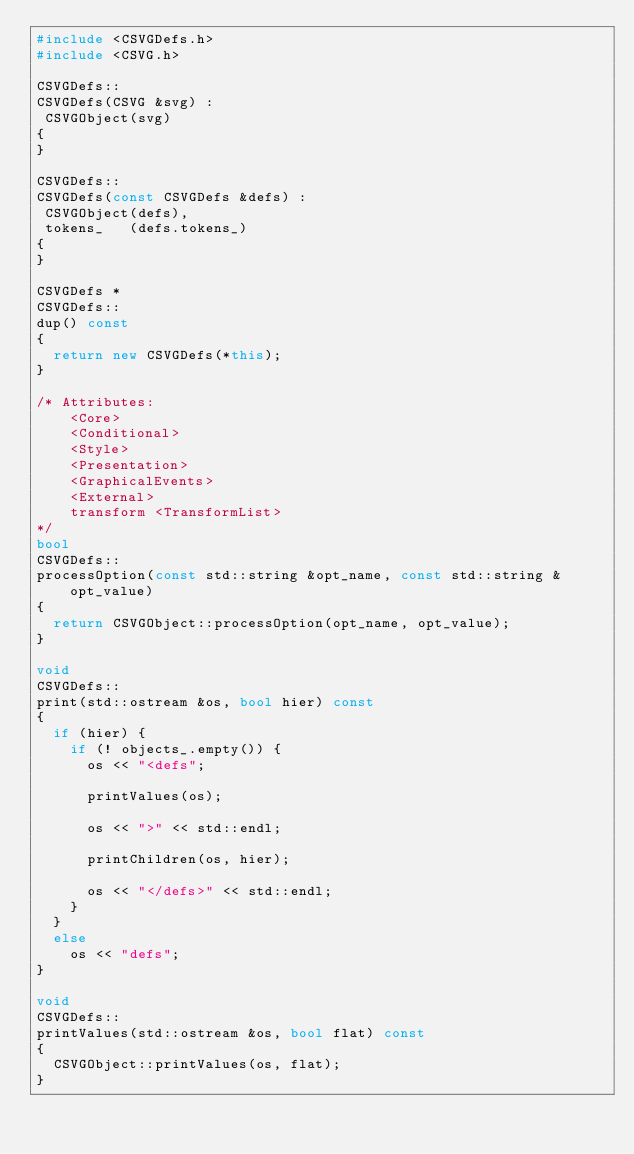<code> <loc_0><loc_0><loc_500><loc_500><_C++_>#include <CSVGDefs.h>
#include <CSVG.h>

CSVGDefs::
CSVGDefs(CSVG &svg) :
 CSVGObject(svg)
{
}

CSVGDefs::
CSVGDefs(const CSVGDefs &defs) :
 CSVGObject(defs),
 tokens_   (defs.tokens_)
{
}

CSVGDefs *
CSVGDefs::
dup() const
{
  return new CSVGDefs(*this);
}

/* Attributes:
    <Core>
    <Conditional>
    <Style>
    <Presentation>
    <GraphicalEvents>
    <External>
    transform <TransformList>
*/
bool
CSVGDefs::
processOption(const std::string &opt_name, const std::string &opt_value)
{
  return CSVGObject::processOption(opt_name, opt_value);
}

void
CSVGDefs::
print(std::ostream &os, bool hier) const
{
  if (hier) {
    if (! objects_.empty()) {
      os << "<defs";

      printValues(os);

      os << ">" << std::endl;

      printChildren(os, hier);

      os << "</defs>" << std::endl;
    }
  }
  else
    os << "defs";
}

void
CSVGDefs::
printValues(std::ostream &os, bool flat) const
{
  CSVGObject::printValues(os, flat);
}
</code> 